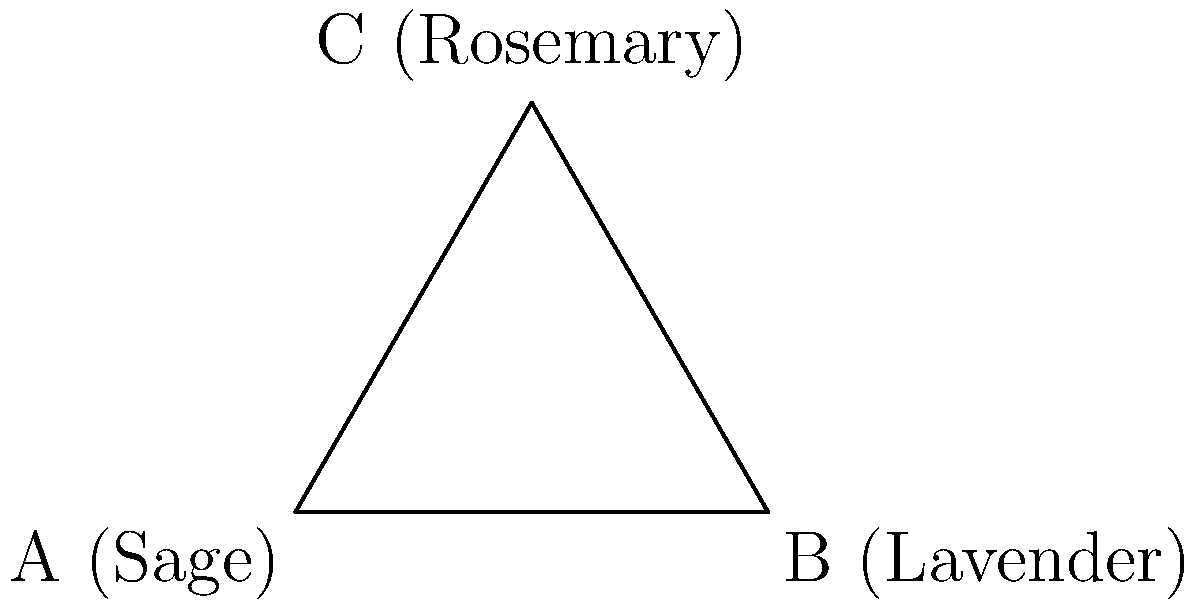In a healing ritual, you use three herbs: Sage, Lavender, and Rosemary. The tribal leader asks about the number of unique ways to arrange these herbs in a circular pattern for the ritual. How many distinct arrangements are possible, considering rotations of the same arrangement as equivalent? To solve this problem, we need to understand the concept of cyclic permutations:

1. First, we have 3 distinct herbs: Sage, Lavender, and Rosemary.

2. In a normal permutation, we would have 3! = 6 possible arrangements.

3. However, since we're arranging them in a circle and rotations are considered equivalent, we need to use cyclic permutations.

4. For cyclic permutations of n distinct objects, the number of unique arrangements is (n-1)!

5. In this case, n = 3, so we calculate:
   $$(n-1)! = (3-1)! = 2! = 2 \times 1 = 2$$

6. Therefore, there are 2 distinct arrangements possible.

These two arrangements are:
1. Sage -> Lavender -> Rosemary
2. Sage -> Rosemary -> Lavender

Any other arrangement would be a rotation of one of these two and thus considered equivalent.
Answer: 2 